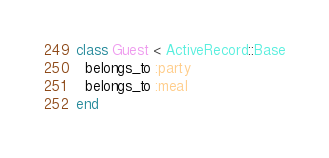<code> <loc_0><loc_0><loc_500><loc_500><_Ruby_>class Guest < ActiveRecord::Base
  belongs_to :party
  belongs_to :meal
end
</code> 